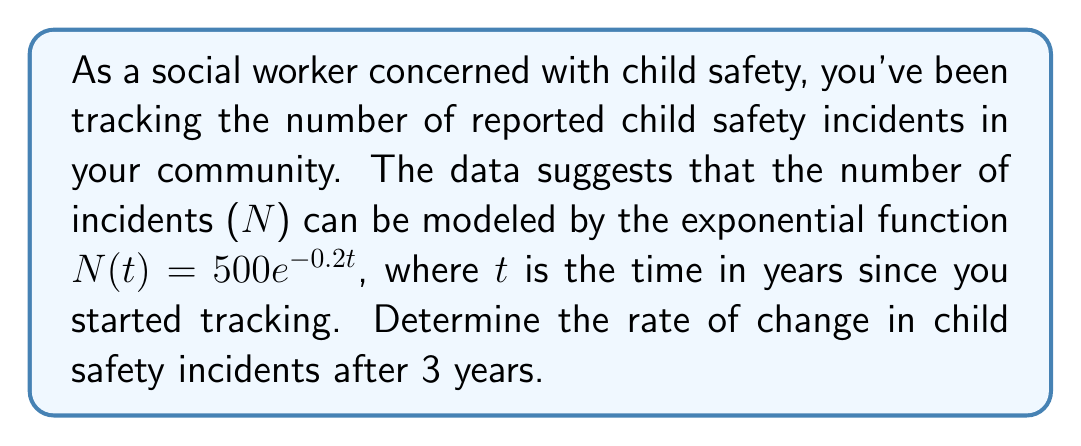What is the answer to this math problem? To find the rate of change in child safety incidents after 3 years, we need to follow these steps:

1) The given function is $N(t) = 500e^{-0.2t}$

2) To find the rate of change, we need to differentiate this function with respect to t:

   $\frac{dN}{dt} = 500 \cdot (-0.2) \cdot e^{-0.2t} = -100e^{-0.2t}$

3) This derivative represents the instantaneous rate of change at any time t.

4) To find the rate of change after 3 years, we substitute t = 3 into this derivative:

   $\frac{dN}{dt}|_{t=3} = -100e^{-0.2(3)} = -100e^{-0.6}$

5) Evaluating this:
   
   $-100e^{-0.6} \approx -54.881$ (rounded to 3 decimal places)

6) The negative sign indicates that the number of incidents is decreasing.

Therefore, after 3 years, the rate of change in child safety incidents is approximately -54.881 incidents per year.
Answer: -54.881 incidents/year 